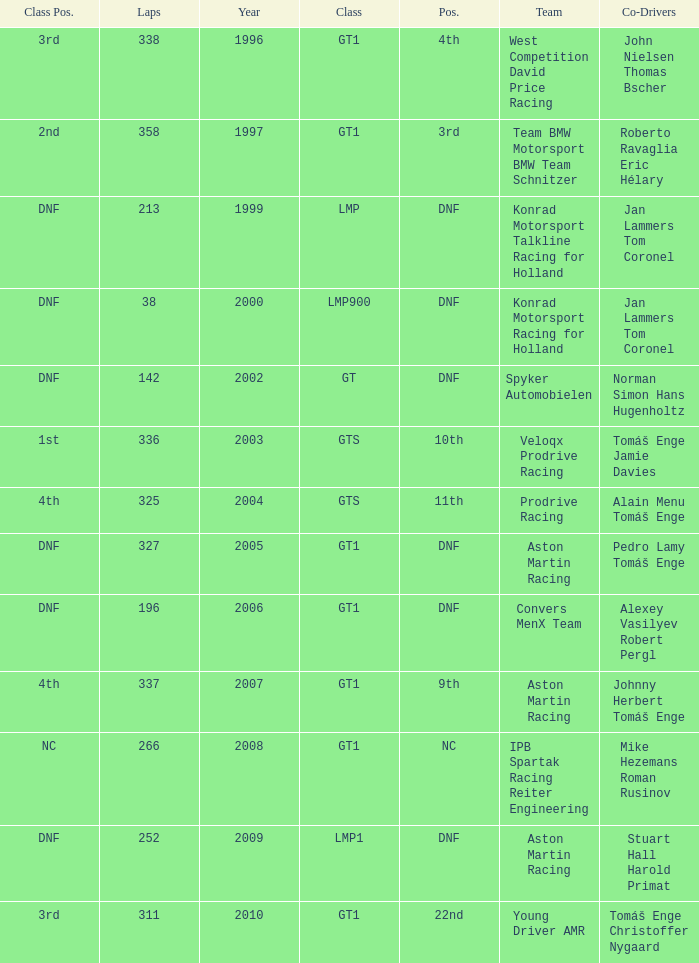Which position finished 3rd in class and completed less than 338 laps? 22nd. 